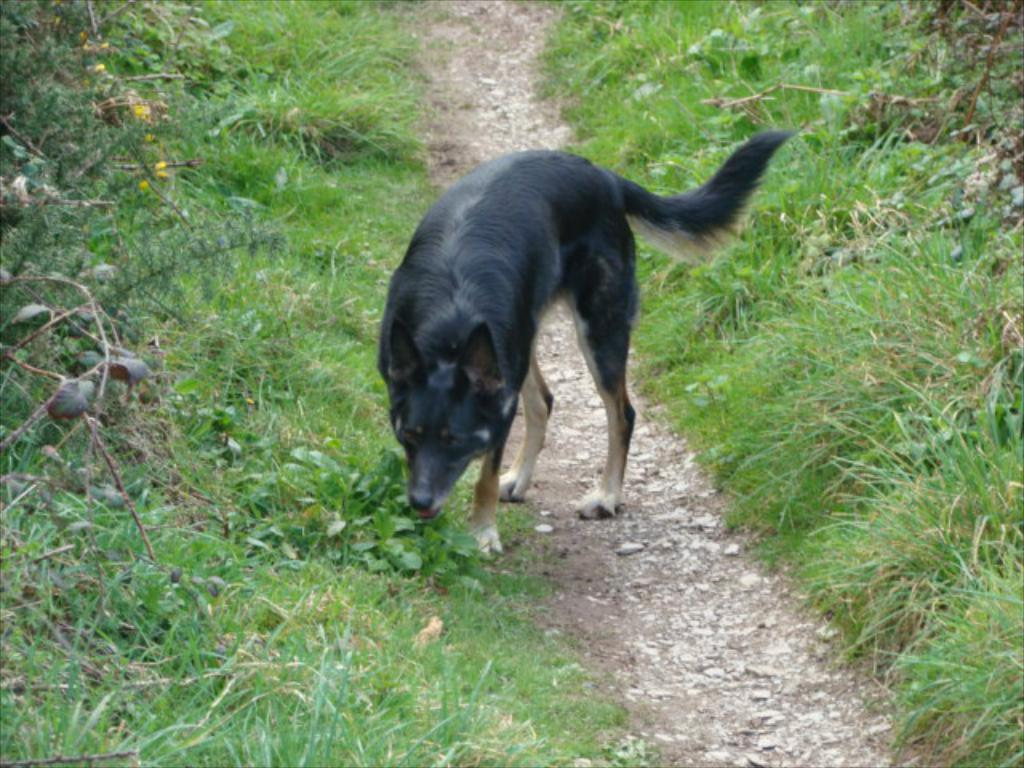What is the main subject in the middle of the image? There is a dog in the middle of the image. What type of vegetation is present on the left side of the image? There is grass on the left side of the image. What type of vegetation is present on the right side of the image? There is grass on the right side of the image. Can you identify any other living organisms in the image? Yes, there are plants in the image. What news headline is visible on the dog's collar in the image? There is no news headline visible on the dog's collar in the image. Is the dog holding a stick in its mouth in the image? There is no stick present in the image, and the dog is not holding anything in its mouth. 